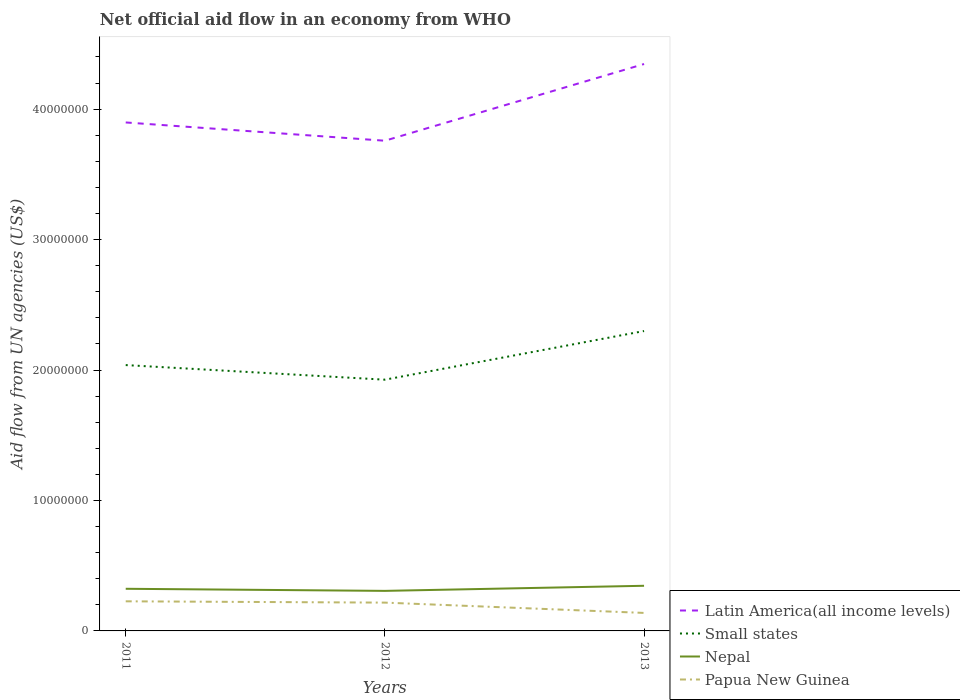How many different coloured lines are there?
Provide a succinct answer. 4. Across all years, what is the maximum net official aid flow in Nepal?
Your answer should be compact. 3.07e+06. In which year was the net official aid flow in Nepal maximum?
Make the answer very short. 2012. What is the total net official aid flow in Nepal in the graph?
Your answer should be compact. -3.90e+05. What is the difference between the highest and the second highest net official aid flow in Latin America(all income levels)?
Offer a terse response. 5.88e+06. What is the difference between the highest and the lowest net official aid flow in Papua New Guinea?
Offer a very short reply. 2. How many lines are there?
Ensure brevity in your answer.  4. What is the difference between two consecutive major ticks on the Y-axis?
Keep it short and to the point. 1.00e+07. Are the values on the major ticks of Y-axis written in scientific E-notation?
Your answer should be compact. No. Does the graph contain any zero values?
Your answer should be very brief. No. Does the graph contain grids?
Provide a short and direct response. No. Where does the legend appear in the graph?
Provide a succinct answer. Bottom right. How many legend labels are there?
Provide a succinct answer. 4. What is the title of the graph?
Your answer should be very brief. Net official aid flow in an economy from WHO. What is the label or title of the X-axis?
Your answer should be compact. Years. What is the label or title of the Y-axis?
Give a very brief answer. Aid flow from UN agencies (US$). What is the Aid flow from UN agencies (US$) in Latin America(all income levels) in 2011?
Offer a terse response. 3.90e+07. What is the Aid flow from UN agencies (US$) in Small states in 2011?
Provide a succinct answer. 2.04e+07. What is the Aid flow from UN agencies (US$) in Nepal in 2011?
Give a very brief answer. 3.23e+06. What is the Aid flow from UN agencies (US$) of Papua New Guinea in 2011?
Give a very brief answer. 2.27e+06. What is the Aid flow from UN agencies (US$) of Latin America(all income levels) in 2012?
Your answer should be very brief. 3.76e+07. What is the Aid flow from UN agencies (US$) in Small states in 2012?
Your answer should be compact. 1.93e+07. What is the Aid flow from UN agencies (US$) in Nepal in 2012?
Provide a succinct answer. 3.07e+06. What is the Aid flow from UN agencies (US$) of Papua New Guinea in 2012?
Offer a terse response. 2.17e+06. What is the Aid flow from UN agencies (US$) of Latin America(all income levels) in 2013?
Ensure brevity in your answer.  4.35e+07. What is the Aid flow from UN agencies (US$) of Small states in 2013?
Provide a short and direct response. 2.30e+07. What is the Aid flow from UN agencies (US$) of Nepal in 2013?
Give a very brief answer. 3.46e+06. What is the Aid flow from UN agencies (US$) of Papua New Guinea in 2013?
Your response must be concise. 1.38e+06. Across all years, what is the maximum Aid flow from UN agencies (US$) in Latin America(all income levels)?
Your response must be concise. 4.35e+07. Across all years, what is the maximum Aid flow from UN agencies (US$) of Small states?
Offer a terse response. 2.30e+07. Across all years, what is the maximum Aid flow from UN agencies (US$) in Nepal?
Make the answer very short. 3.46e+06. Across all years, what is the maximum Aid flow from UN agencies (US$) of Papua New Guinea?
Make the answer very short. 2.27e+06. Across all years, what is the minimum Aid flow from UN agencies (US$) in Latin America(all income levels)?
Ensure brevity in your answer.  3.76e+07. Across all years, what is the minimum Aid flow from UN agencies (US$) in Small states?
Offer a terse response. 1.93e+07. Across all years, what is the minimum Aid flow from UN agencies (US$) of Nepal?
Your response must be concise. 3.07e+06. Across all years, what is the minimum Aid flow from UN agencies (US$) in Papua New Guinea?
Keep it short and to the point. 1.38e+06. What is the total Aid flow from UN agencies (US$) in Latin America(all income levels) in the graph?
Offer a very short reply. 1.20e+08. What is the total Aid flow from UN agencies (US$) in Small states in the graph?
Your answer should be compact. 6.26e+07. What is the total Aid flow from UN agencies (US$) in Nepal in the graph?
Your answer should be compact. 9.76e+06. What is the total Aid flow from UN agencies (US$) in Papua New Guinea in the graph?
Keep it short and to the point. 5.82e+06. What is the difference between the Aid flow from UN agencies (US$) of Latin America(all income levels) in 2011 and that in 2012?
Provide a succinct answer. 1.40e+06. What is the difference between the Aid flow from UN agencies (US$) in Small states in 2011 and that in 2012?
Your answer should be compact. 1.12e+06. What is the difference between the Aid flow from UN agencies (US$) of Nepal in 2011 and that in 2012?
Ensure brevity in your answer.  1.60e+05. What is the difference between the Aid flow from UN agencies (US$) in Latin America(all income levels) in 2011 and that in 2013?
Provide a succinct answer. -4.48e+06. What is the difference between the Aid flow from UN agencies (US$) of Small states in 2011 and that in 2013?
Make the answer very short. -2.61e+06. What is the difference between the Aid flow from UN agencies (US$) in Nepal in 2011 and that in 2013?
Give a very brief answer. -2.30e+05. What is the difference between the Aid flow from UN agencies (US$) of Papua New Guinea in 2011 and that in 2013?
Your response must be concise. 8.90e+05. What is the difference between the Aid flow from UN agencies (US$) of Latin America(all income levels) in 2012 and that in 2013?
Your answer should be very brief. -5.88e+06. What is the difference between the Aid flow from UN agencies (US$) of Small states in 2012 and that in 2013?
Keep it short and to the point. -3.73e+06. What is the difference between the Aid flow from UN agencies (US$) in Nepal in 2012 and that in 2013?
Make the answer very short. -3.90e+05. What is the difference between the Aid flow from UN agencies (US$) of Papua New Guinea in 2012 and that in 2013?
Your response must be concise. 7.90e+05. What is the difference between the Aid flow from UN agencies (US$) of Latin America(all income levels) in 2011 and the Aid flow from UN agencies (US$) of Small states in 2012?
Your answer should be compact. 1.97e+07. What is the difference between the Aid flow from UN agencies (US$) of Latin America(all income levels) in 2011 and the Aid flow from UN agencies (US$) of Nepal in 2012?
Keep it short and to the point. 3.59e+07. What is the difference between the Aid flow from UN agencies (US$) in Latin America(all income levels) in 2011 and the Aid flow from UN agencies (US$) in Papua New Guinea in 2012?
Give a very brief answer. 3.68e+07. What is the difference between the Aid flow from UN agencies (US$) of Small states in 2011 and the Aid flow from UN agencies (US$) of Nepal in 2012?
Offer a very short reply. 1.73e+07. What is the difference between the Aid flow from UN agencies (US$) of Small states in 2011 and the Aid flow from UN agencies (US$) of Papua New Guinea in 2012?
Offer a terse response. 1.82e+07. What is the difference between the Aid flow from UN agencies (US$) in Nepal in 2011 and the Aid flow from UN agencies (US$) in Papua New Guinea in 2012?
Offer a very short reply. 1.06e+06. What is the difference between the Aid flow from UN agencies (US$) of Latin America(all income levels) in 2011 and the Aid flow from UN agencies (US$) of Small states in 2013?
Your answer should be compact. 1.60e+07. What is the difference between the Aid flow from UN agencies (US$) in Latin America(all income levels) in 2011 and the Aid flow from UN agencies (US$) in Nepal in 2013?
Your answer should be very brief. 3.55e+07. What is the difference between the Aid flow from UN agencies (US$) in Latin America(all income levels) in 2011 and the Aid flow from UN agencies (US$) in Papua New Guinea in 2013?
Your answer should be very brief. 3.76e+07. What is the difference between the Aid flow from UN agencies (US$) of Small states in 2011 and the Aid flow from UN agencies (US$) of Nepal in 2013?
Make the answer very short. 1.69e+07. What is the difference between the Aid flow from UN agencies (US$) of Small states in 2011 and the Aid flow from UN agencies (US$) of Papua New Guinea in 2013?
Offer a very short reply. 1.90e+07. What is the difference between the Aid flow from UN agencies (US$) in Nepal in 2011 and the Aid flow from UN agencies (US$) in Papua New Guinea in 2013?
Your response must be concise. 1.85e+06. What is the difference between the Aid flow from UN agencies (US$) in Latin America(all income levels) in 2012 and the Aid flow from UN agencies (US$) in Small states in 2013?
Provide a succinct answer. 1.46e+07. What is the difference between the Aid flow from UN agencies (US$) in Latin America(all income levels) in 2012 and the Aid flow from UN agencies (US$) in Nepal in 2013?
Give a very brief answer. 3.41e+07. What is the difference between the Aid flow from UN agencies (US$) in Latin America(all income levels) in 2012 and the Aid flow from UN agencies (US$) in Papua New Guinea in 2013?
Your answer should be very brief. 3.62e+07. What is the difference between the Aid flow from UN agencies (US$) in Small states in 2012 and the Aid flow from UN agencies (US$) in Nepal in 2013?
Provide a succinct answer. 1.58e+07. What is the difference between the Aid flow from UN agencies (US$) of Small states in 2012 and the Aid flow from UN agencies (US$) of Papua New Guinea in 2013?
Provide a short and direct response. 1.79e+07. What is the difference between the Aid flow from UN agencies (US$) in Nepal in 2012 and the Aid flow from UN agencies (US$) in Papua New Guinea in 2013?
Offer a very short reply. 1.69e+06. What is the average Aid flow from UN agencies (US$) of Latin America(all income levels) per year?
Your answer should be very brief. 4.00e+07. What is the average Aid flow from UN agencies (US$) of Small states per year?
Make the answer very short. 2.09e+07. What is the average Aid flow from UN agencies (US$) in Nepal per year?
Make the answer very short. 3.25e+06. What is the average Aid flow from UN agencies (US$) in Papua New Guinea per year?
Offer a terse response. 1.94e+06. In the year 2011, what is the difference between the Aid flow from UN agencies (US$) in Latin America(all income levels) and Aid flow from UN agencies (US$) in Small states?
Provide a succinct answer. 1.86e+07. In the year 2011, what is the difference between the Aid flow from UN agencies (US$) of Latin America(all income levels) and Aid flow from UN agencies (US$) of Nepal?
Offer a very short reply. 3.58e+07. In the year 2011, what is the difference between the Aid flow from UN agencies (US$) of Latin America(all income levels) and Aid flow from UN agencies (US$) of Papua New Guinea?
Make the answer very short. 3.67e+07. In the year 2011, what is the difference between the Aid flow from UN agencies (US$) of Small states and Aid flow from UN agencies (US$) of Nepal?
Your response must be concise. 1.72e+07. In the year 2011, what is the difference between the Aid flow from UN agencies (US$) in Small states and Aid flow from UN agencies (US$) in Papua New Guinea?
Offer a very short reply. 1.81e+07. In the year 2011, what is the difference between the Aid flow from UN agencies (US$) of Nepal and Aid flow from UN agencies (US$) of Papua New Guinea?
Offer a terse response. 9.60e+05. In the year 2012, what is the difference between the Aid flow from UN agencies (US$) of Latin America(all income levels) and Aid flow from UN agencies (US$) of Small states?
Make the answer very short. 1.83e+07. In the year 2012, what is the difference between the Aid flow from UN agencies (US$) of Latin America(all income levels) and Aid flow from UN agencies (US$) of Nepal?
Keep it short and to the point. 3.45e+07. In the year 2012, what is the difference between the Aid flow from UN agencies (US$) of Latin America(all income levels) and Aid flow from UN agencies (US$) of Papua New Guinea?
Your answer should be compact. 3.54e+07. In the year 2012, what is the difference between the Aid flow from UN agencies (US$) of Small states and Aid flow from UN agencies (US$) of Nepal?
Provide a succinct answer. 1.62e+07. In the year 2012, what is the difference between the Aid flow from UN agencies (US$) of Small states and Aid flow from UN agencies (US$) of Papua New Guinea?
Your answer should be compact. 1.71e+07. In the year 2013, what is the difference between the Aid flow from UN agencies (US$) in Latin America(all income levels) and Aid flow from UN agencies (US$) in Small states?
Provide a short and direct response. 2.05e+07. In the year 2013, what is the difference between the Aid flow from UN agencies (US$) of Latin America(all income levels) and Aid flow from UN agencies (US$) of Nepal?
Make the answer very short. 4.00e+07. In the year 2013, what is the difference between the Aid flow from UN agencies (US$) in Latin America(all income levels) and Aid flow from UN agencies (US$) in Papua New Guinea?
Your answer should be compact. 4.21e+07. In the year 2013, what is the difference between the Aid flow from UN agencies (US$) in Small states and Aid flow from UN agencies (US$) in Nepal?
Provide a succinct answer. 1.95e+07. In the year 2013, what is the difference between the Aid flow from UN agencies (US$) in Small states and Aid flow from UN agencies (US$) in Papua New Guinea?
Ensure brevity in your answer.  2.16e+07. In the year 2013, what is the difference between the Aid flow from UN agencies (US$) in Nepal and Aid flow from UN agencies (US$) in Papua New Guinea?
Your answer should be compact. 2.08e+06. What is the ratio of the Aid flow from UN agencies (US$) in Latin America(all income levels) in 2011 to that in 2012?
Give a very brief answer. 1.04. What is the ratio of the Aid flow from UN agencies (US$) in Small states in 2011 to that in 2012?
Offer a terse response. 1.06. What is the ratio of the Aid flow from UN agencies (US$) of Nepal in 2011 to that in 2012?
Your answer should be very brief. 1.05. What is the ratio of the Aid flow from UN agencies (US$) of Papua New Guinea in 2011 to that in 2012?
Provide a short and direct response. 1.05. What is the ratio of the Aid flow from UN agencies (US$) of Latin America(all income levels) in 2011 to that in 2013?
Your answer should be very brief. 0.9. What is the ratio of the Aid flow from UN agencies (US$) of Small states in 2011 to that in 2013?
Your answer should be very brief. 0.89. What is the ratio of the Aid flow from UN agencies (US$) of Nepal in 2011 to that in 2013?
Give a very brief answer. 0.93. What is the ratio of the Aid flow from UN agencies (US$) of Papua New Guinea in 2011 to that in 2013?
Provide a succinct answer. 1.64. What is the ratio of the Aid flow from UN agencies (US$) of Latin America(all income levels) in 2012 to that in 2013?
Your answer should be compact. 0.86. What is the ratio of the Aid flow from UN agencies (US$) in Small states in 2012 to that in 2013?
Provide a succinct answer. 0.84. What is the ratio of the Aid flow from UN agencies (US$) in Nepal in 2012 to that in 2013?
Ensure brevity in your answer.  0.89. What is the ratio of the Aid flow from UN agencies (US$) of Papua New Guinea in 2012 to that in 2013?
Make the answer very short. 1.57. What is the difference between the highest and the second highest Aid flow from UN agencies (US$) in Latin America(all income levels)?
Your answer should be compact. 4.48e+06. What is the difference between the highest and the second highest Aid flow from UN agencies (US$) of Small states?
Offer a very short reply. 2.61e+06. What is the difference between the highest and the second highest Aid flow from UN agencies (US$) of Nepal?
Make the answer very short. 2.30e+05. What is the difference between the highest and the lowest Aid flow from UN agencies (US$) in Latin America(all income levels)?
Provide a short and direct response. 5.88e+06. What is the difference between the highest and the lowest Aid flow from UN agencies (US$) of Small states?
Make the answer very short. 3.73e+06. What is the difference between the highest and the lowest Aid flow from UN agencies (US$) in Nepal?
Provide a succinct answer. 3.90e+05. What is the difference between the highest and the lowest Aid flow from UN agencies (US$) in Papua New Guinea?
Ensure brevity in your answer.  8.90e+05. 